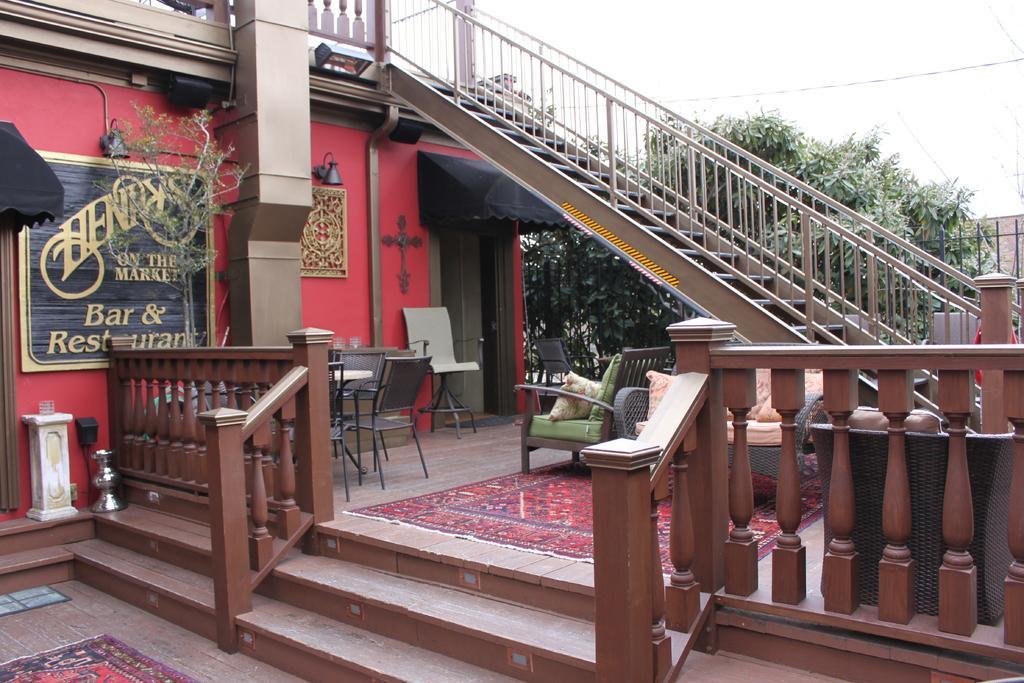How would you summarize this image in a sentence or two? In this image we can see stairs, trees, name board, frame, lights, sofa and table with chairs and also carpets. I can also see a black color fence. 